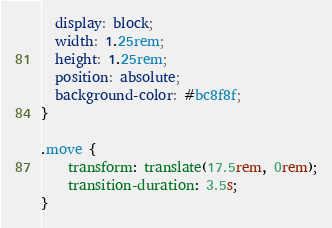Convert code to text. <code><loc_0><loc_0><loc_500><loc_500><_CSS_>  display: block;
  width: 1.25rem;
  height: 1.25rem;
  position: absolute;
  background-color: #bc8f8f;
}

.move {
	transform: translate(17.5rem, 0rem);
	transition-duration: 3.5s;
}</code> 